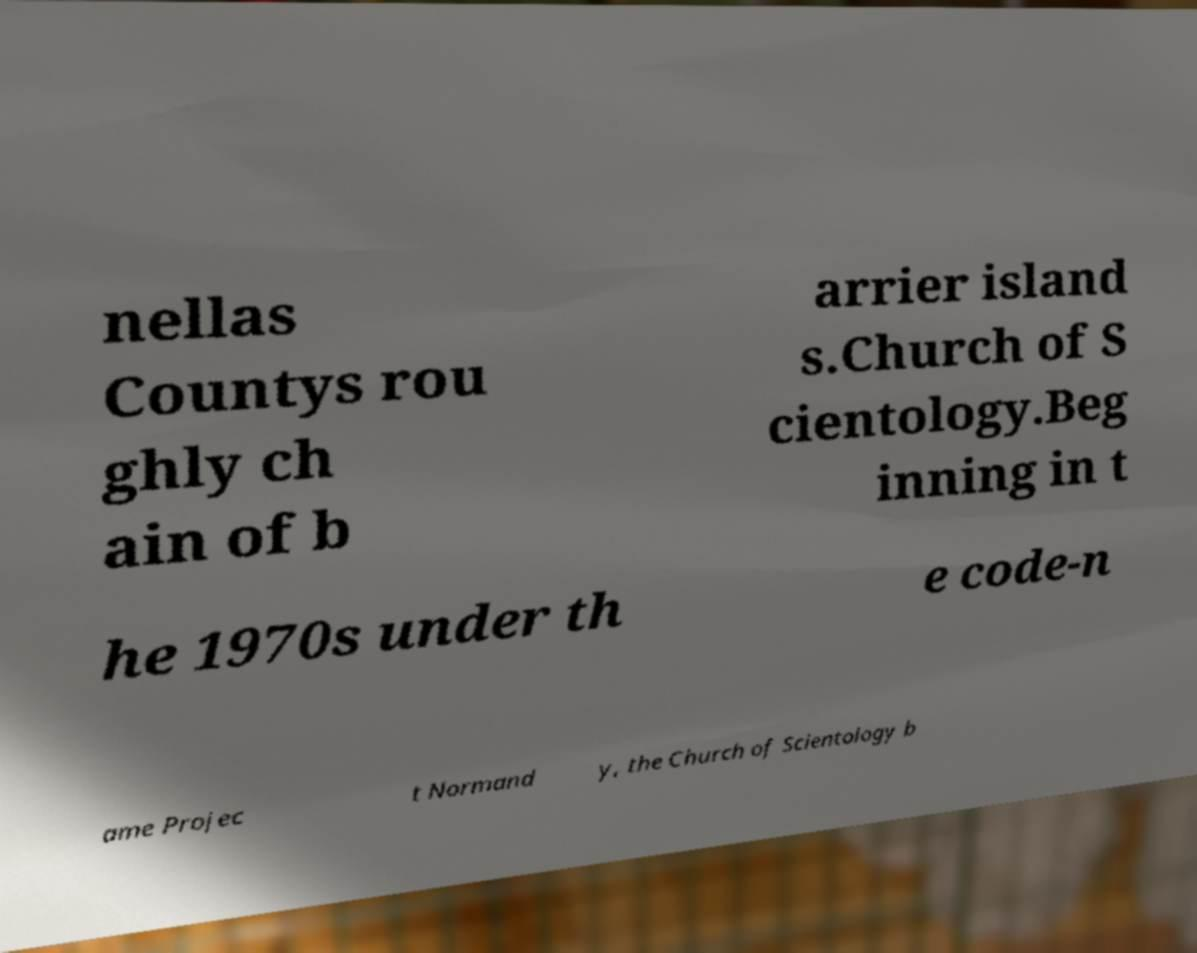Please identify and transcribe the text found in this image. nellas Countys rou ghly ch ain of b arrier island s.Church of S cientology.Beg inning in t he 1970s under th e code-n ame Projec t Normand y, the Church of Scientology b 